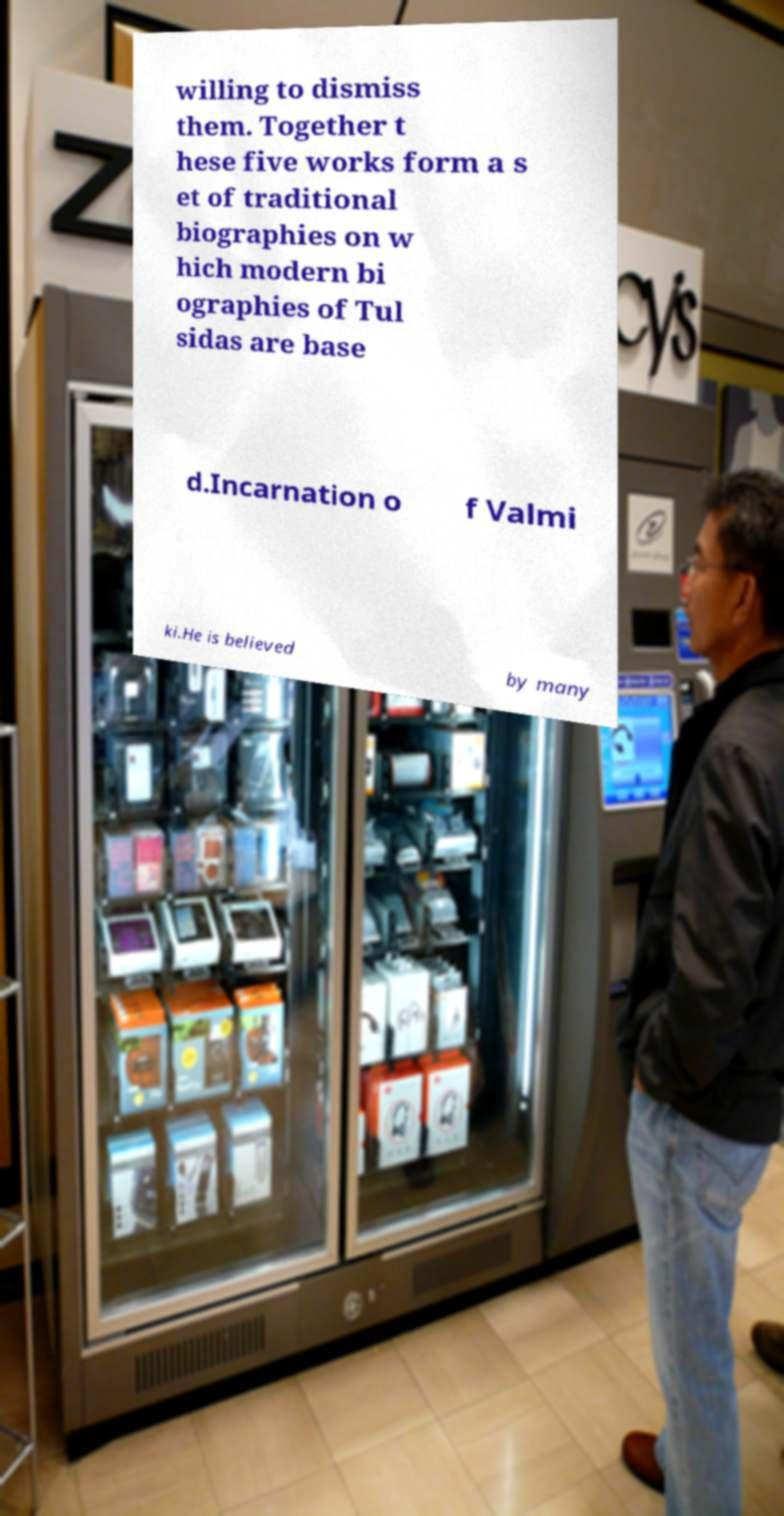Could you extract and type out the text from this image? willing to dismiss them. Together t hese five works form a s et of traditional biographies on w hich modern bi ographies of Tul sidas are base d.Incarnation o f Valmi ki.He is believed by many 